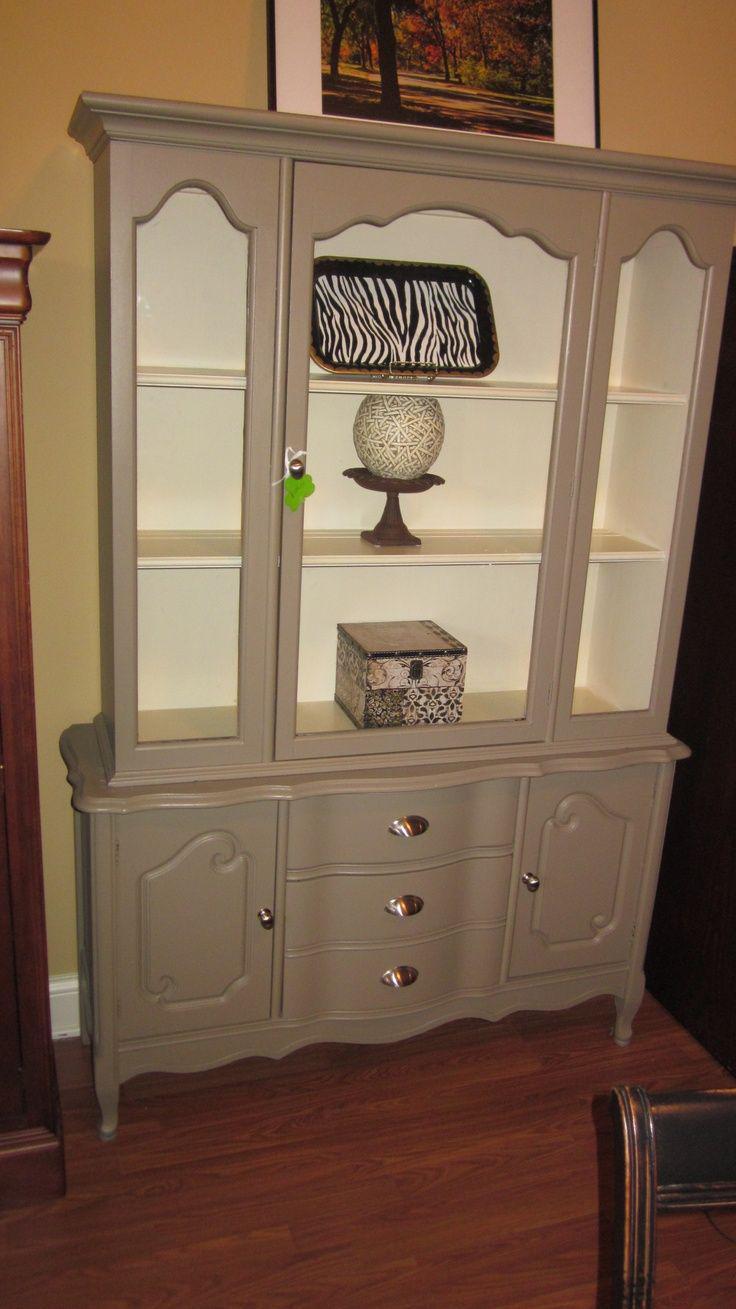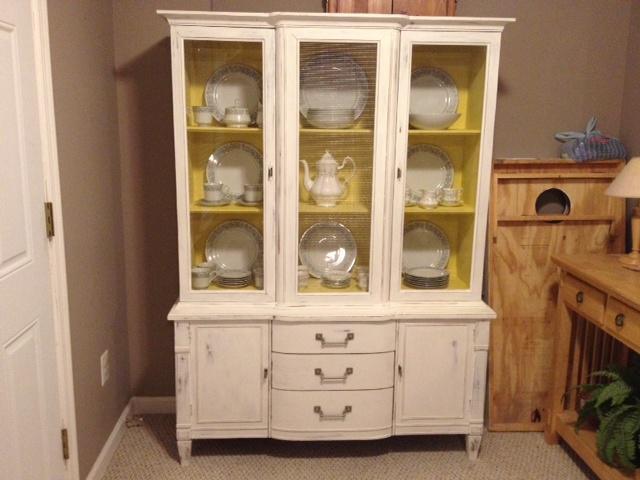The first image is the image on the left, the second image is the image on the right. Examine the images to the left and right. Is the description "At least one white furniture contain dishes." accurate? Answer yes or no. Yes. 